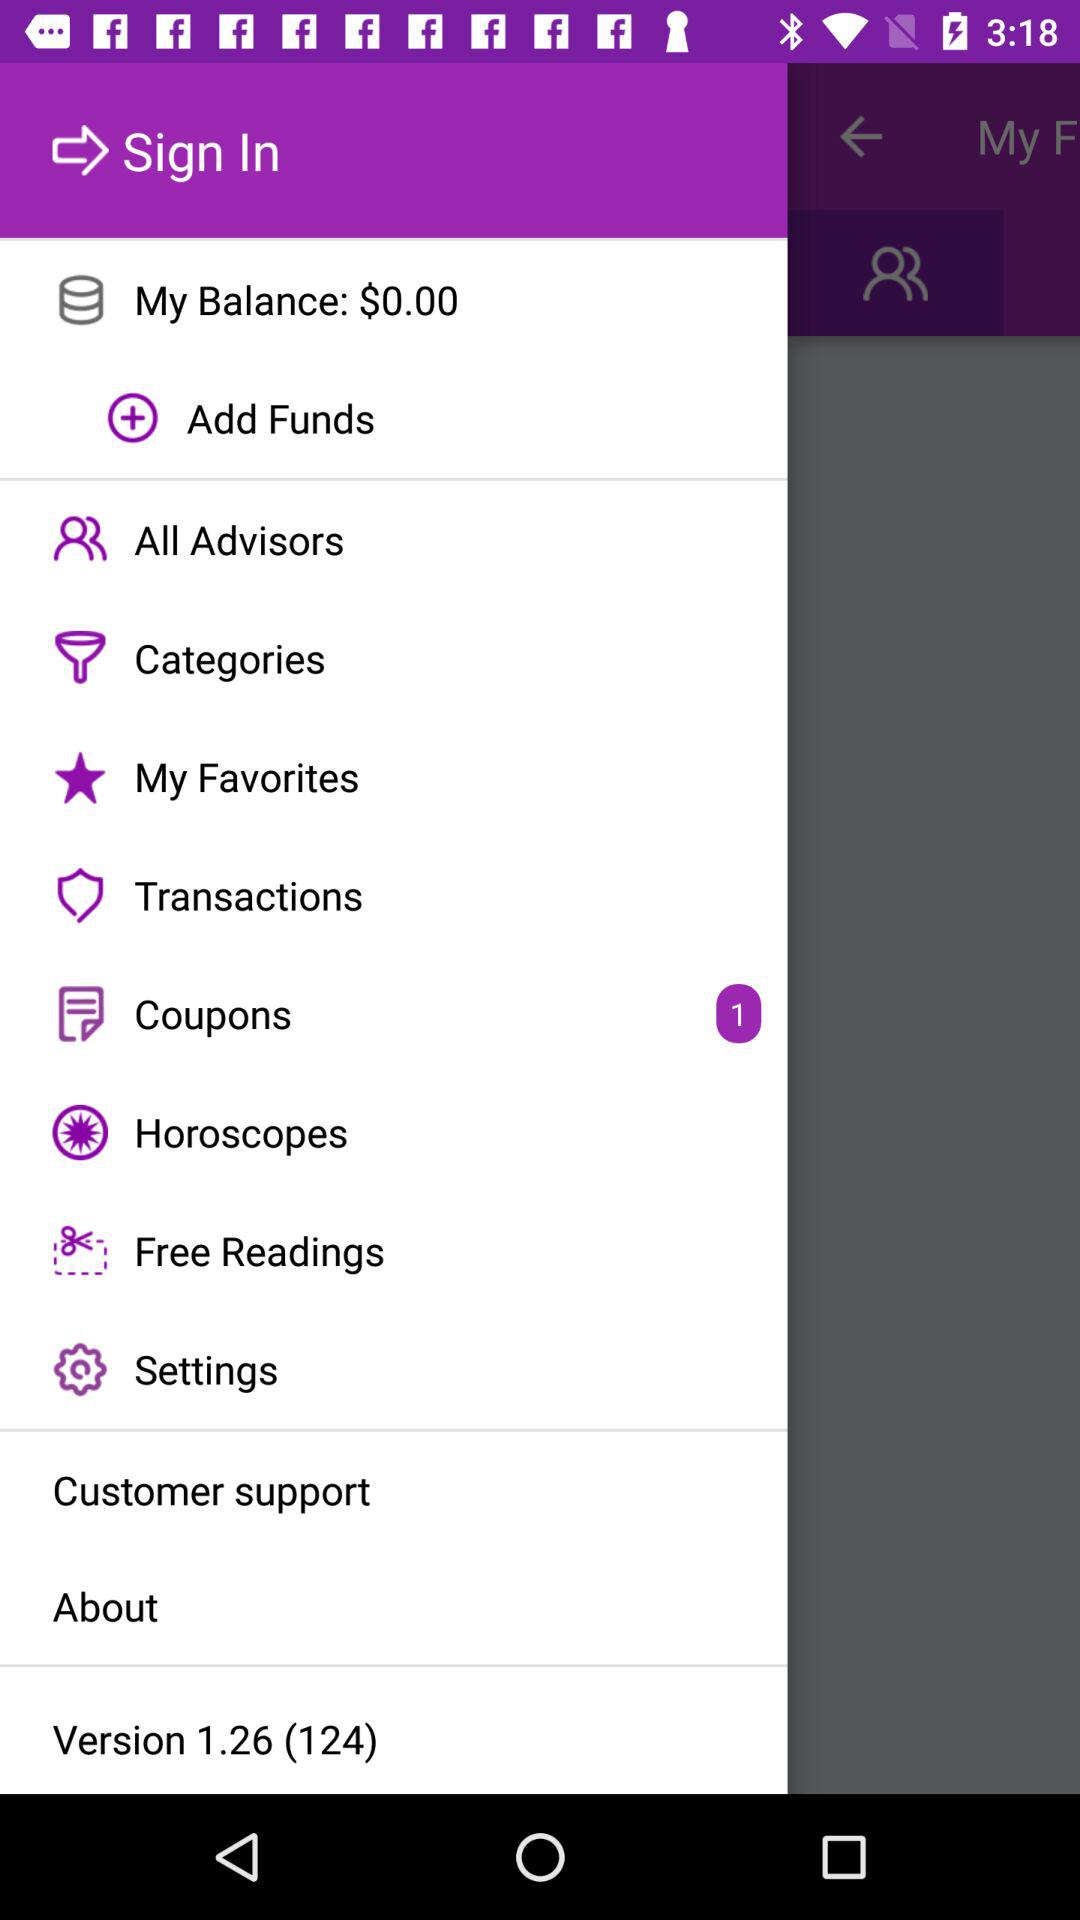What is the current balance on my account? The current balance is $0.00. 